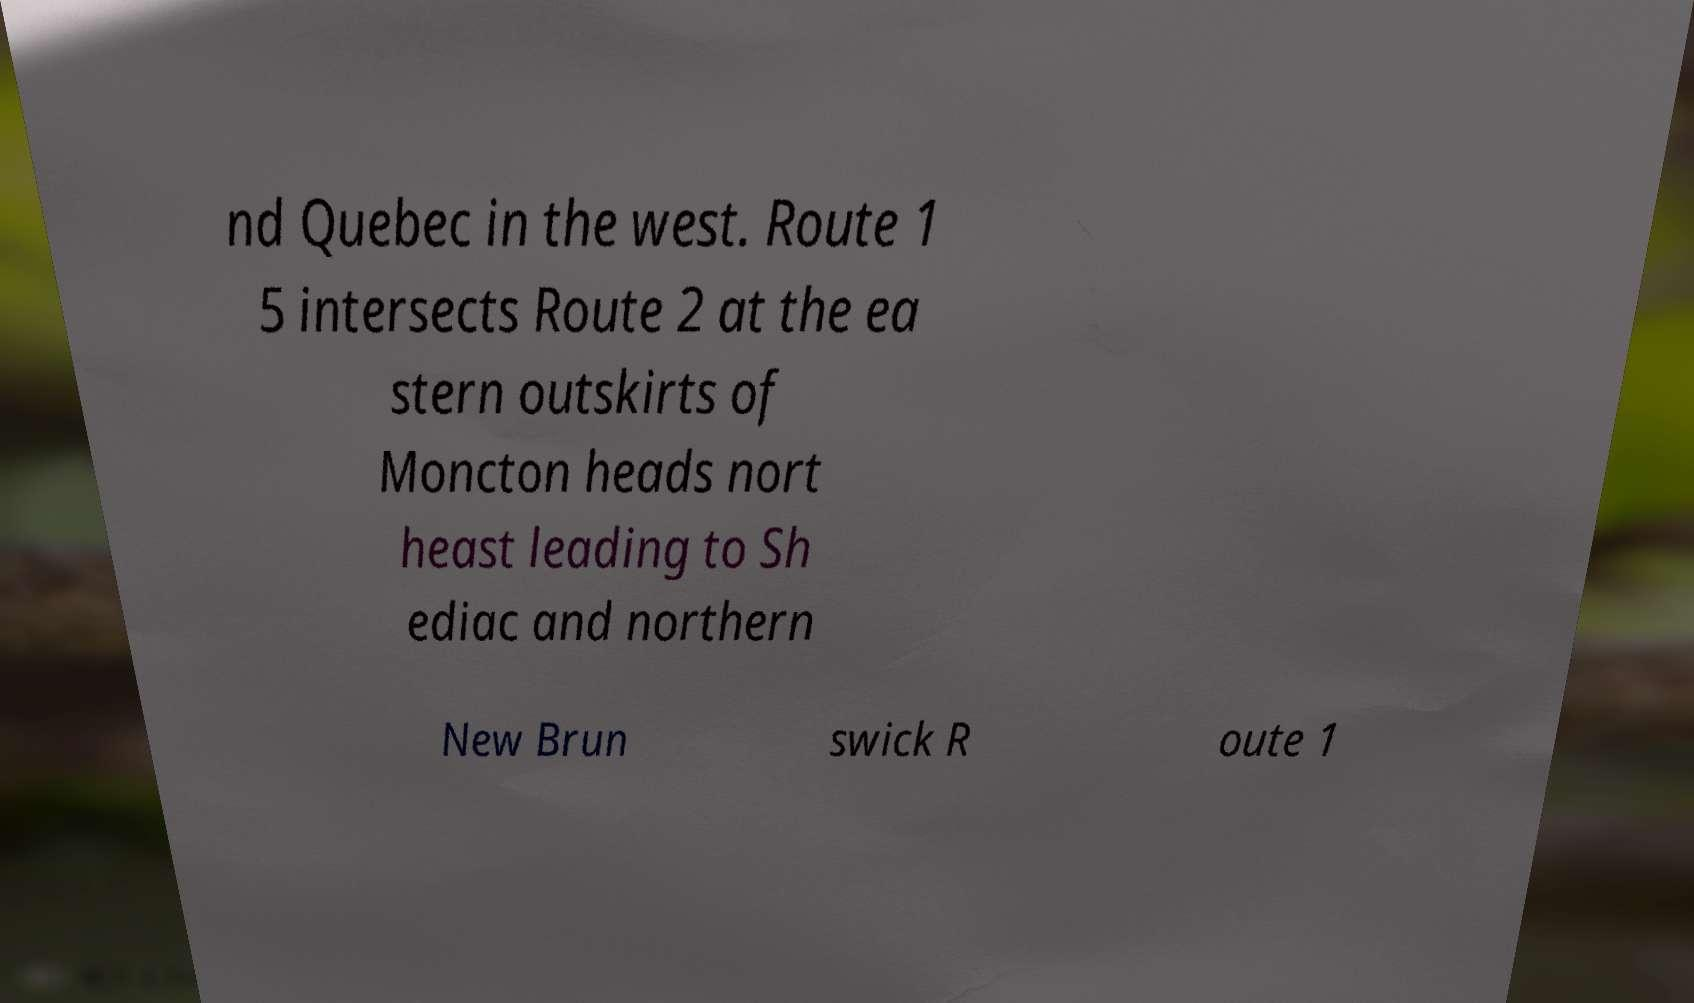Please identify and transcribe the text found in this image. nd Quebec in the west. Route 1 5 intersects Route 2 at the ea stern outskirts of Moncton heads nort heast leading to Sh ediac and northern New Brun swick R oute 1 